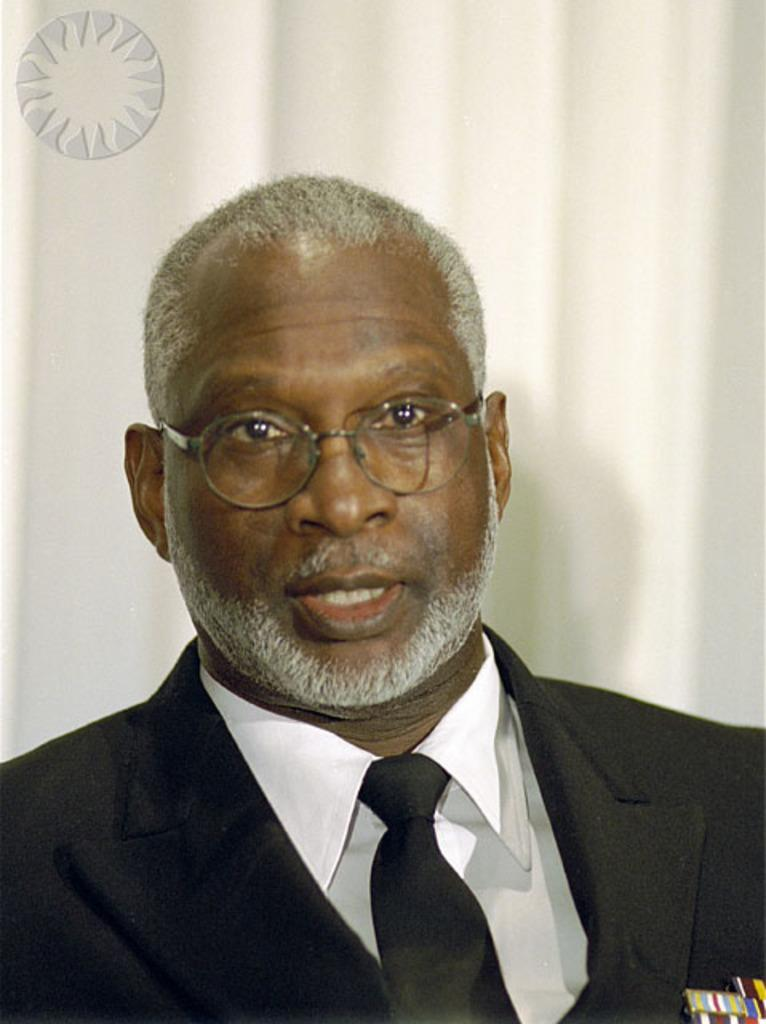Who or what is the main subject in the image? There is a person in the image. What is the background of the image? The person is on a white background. What is the person wearing? The person is wearing clothes and spectacles. Is there any text or symbol in the image? Yes, there is a logo in the top left of the image. Are there any ants crawling on the person's clothes in the image? No, there are no ants present in the image. What type of toys can be seen on the white background? There are no toys visible in the image; it features a person with a logo in the top left corner. 